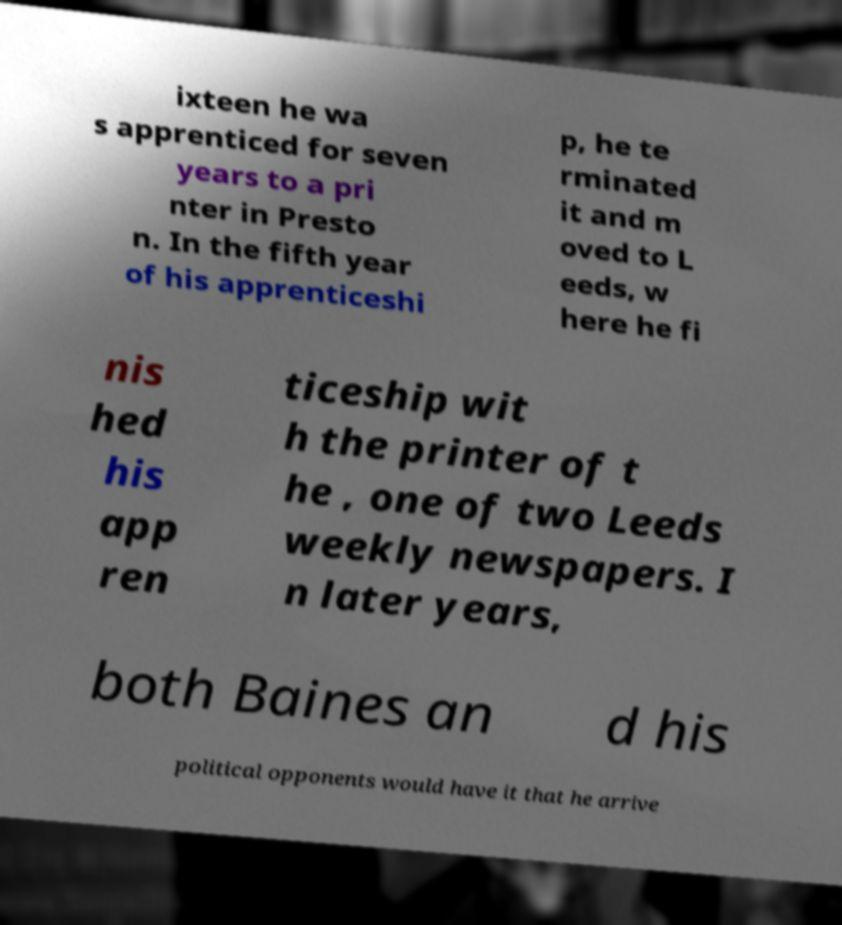What messages or text are displayed in this image? I need them in a readable, typed format. ixteen he wa s apprenticed for seven years to a pri nter in Presto n. In the fifth year of his apprenticeshi p, he te rminated it and m oved to L eeds, w here he fi nis hed his app ren ticeship wit h the printer of t he , one of two Leeds weekly newspapers. I n later years, both Baines an d his political opponents would have it that he arrive 